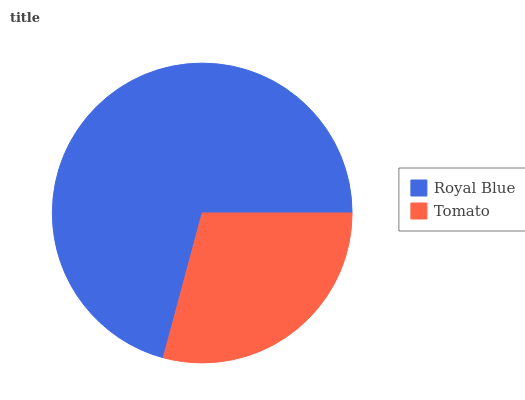Is Tomato the minimum?
Answer yes or no. Yes. Is Royal Blue the maximum?
Answer yes or no. Yes. Is Tomato the maximum?
Answer yes or no. No. Is Royal Blue greater than Tomato?
Answer yes or no. Yes. Is Tomato less than Royal Blue?
Answer yes or no. Yes. Is Tomato greater than Royal Blue?
Answer yes or no. No. Is Royal Blue less than Tomato?
Answer yes or no. No. Is Royal Blue the high median?
Answer yes or no. Yes. Is Tomato the low median?
Answer yes or no. Yes. Is Tomato the high median?
Answer yes or no. No. Is Royal Blue the low median?
Answer yes or no. No. 